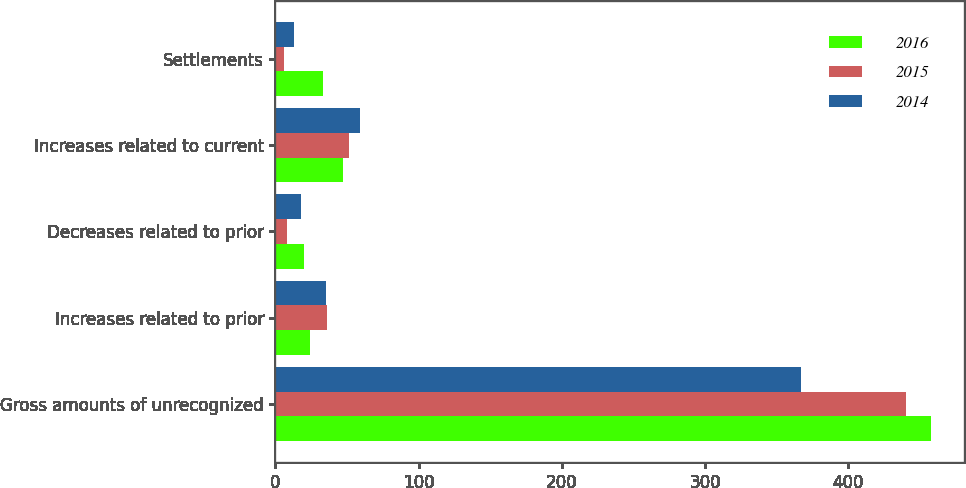Convert chart. <chart><loc_0><loc_0><loc_500><loc_500><stacked_bar_chart><ecel><fcel>Gross amounts of unrecognized<fcel>Increases related to prior<fcel>Decreases related to prior<fcel>Increases related to current<fcel>Settlements<nl><fcel>2016<fcel>458<fcel>24<fcel>20<fcel>47<fcel>33<nl><fcel>2015<fcel>440<fcel>36<fcel>8<fcel>51<fcel>6<nl><fcel>2014<fcel>367<fcel>35<fcel>18<fcel>59<fcel>13<nl></chart> 